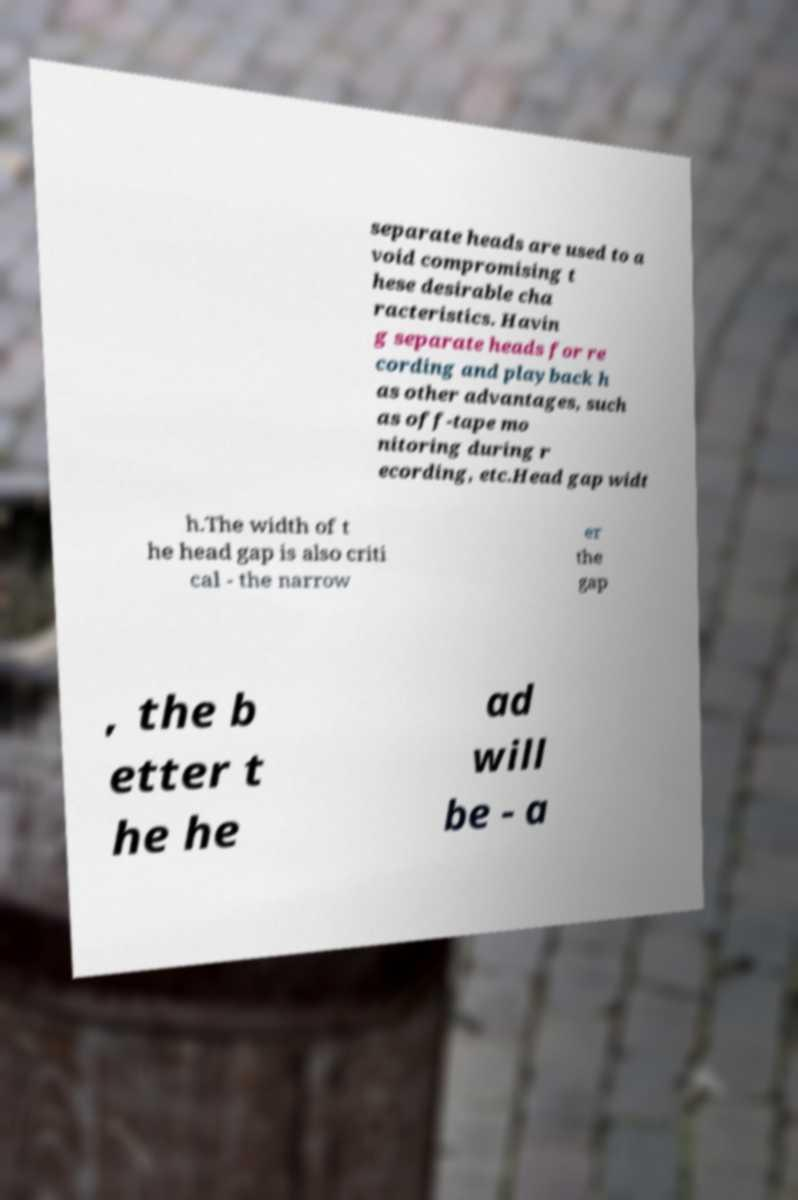I need the written content from this picture converted into text. Can you do that? separate heads are used to a void compromising t hese desirable cha racteristics. Havin g separate heads for re cording and playback h as other advantages, such as off-tape mo nitoring during r ecording, etc.Head gap widt h.The width of t he head gap is also criti cal - the narrow er the gap , the b etter t he he ad will be - a 